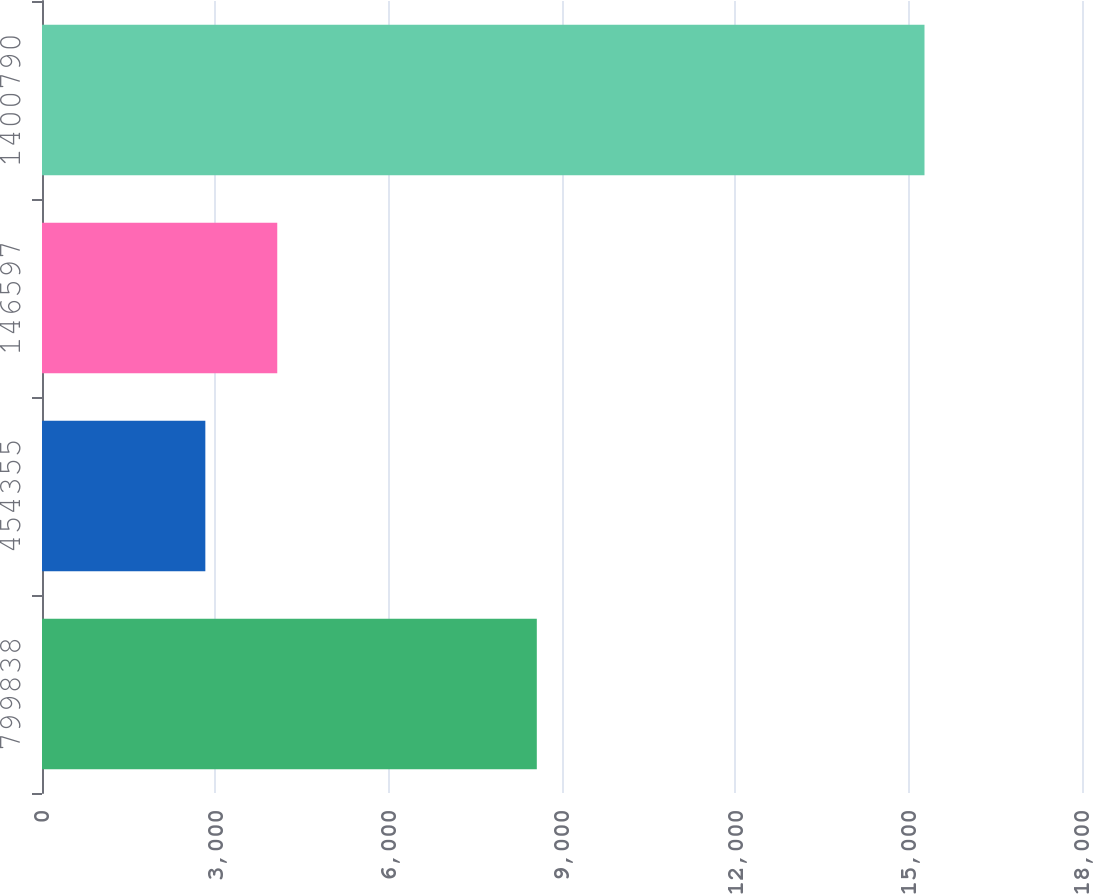Convert chart to OTSL. <chart><loc_0><loc_0><loc_500><loc_500><bar_chart><fcel>799838<fcel>454355<fcel>146597<fcel>1400790<nl><fcel>8564<fcel>2827<fcel>4071.7<fcel>15274<nl></chart> 